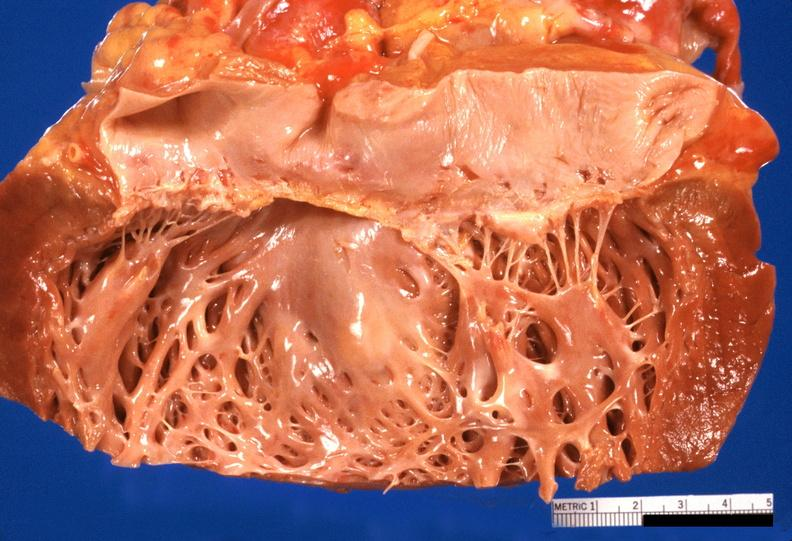where is this?
Answer the question using a single word or phrase. Heart 